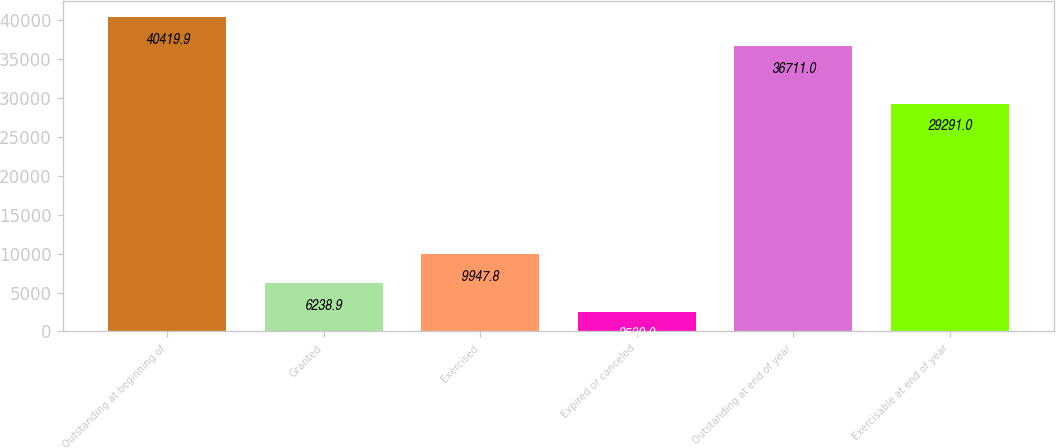Convert chart to OTSL. <chart><loc_0><loc_0><loc_500><loc_500><bar_chart><fcel>Outstanding at beginning of<fcel>Granted<fcel>Exercised<fcel>Expired or canceled<fcel>Outstanding at end of year<fcel>Exercisable at end of year<nl><fcel>40419.9<fcel>6238.9<fcel>9947.8<fcel>2530<fcel>36711<fcel>29291<nl></chart> 